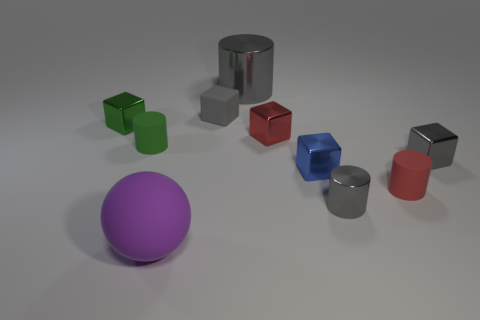Subtract all small red cylinders. How many cylinders are left? 3 Subtract all cyan balls. How many gray blocks are left? 2 Subtract 1 cylinders. How many cylinders are left? 3 Subtract all green cylinders. How many cylinders are left? 3 Subtract all balls. How many objects are left? 9 Subtract all large rubber cylinders. Subtract all large purple rubber objects. How many objects are left? 9 Add 2 large metallic cylinders. How many large metallic cylinders are left? 3 Add 1 large gray cylinders. How many large gray cylinders exist? 2 Subtract 1 green cylinders. How many objects are left? 9 Subtract all gray cylinders. Subtract all cyan blocks. How many cylinders are left? 2 